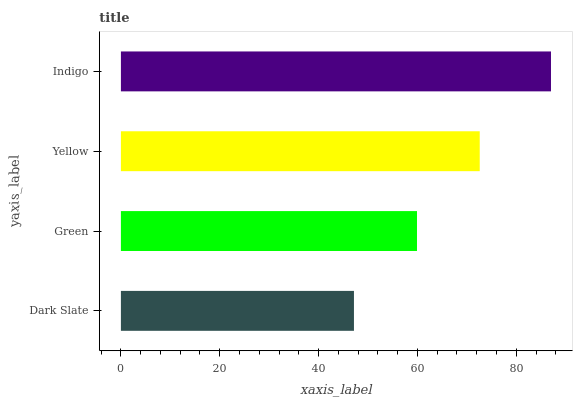Is Dark Slate the minimum?
Answer yes or no. Yes. Is Indigo the maximum?
Answer yes or no. Yes. Is Green the minimum?
Answer yes or no. No. Is Green the maximum?
Answer yes or no. No. Is Green greater than Dark Slate?
Answer yes or no. Yes. Is Dark Slate less than Green?
Answer yes or no. Yes. Is Dark Slate greater than Green?
Answer yes or no. No. Is Green less than Dark Slate?
Answer yes or no. No. Is Yellow the high median?
Answer yes or no. Yes. Is Green the low median?
Answer yes or no. Yes. Is Indigo the high median?
Answer yes or no. No. Is Yellow the low median?
Answer yes or no. No. 